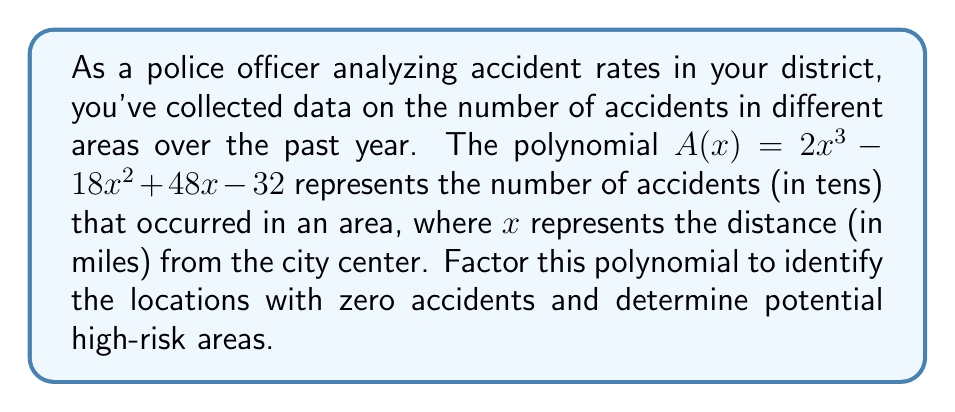Could you help me with this problem? To factor the polynomial $A(x) = 2x^3 - 18x^2 + 48x - 32$, we'll follow these steps:

1) First, let's check if there's a common factor:
   $2x^3 - 18x^2 + 48x - 32 = 2(x^3 - 9x^2 + 24x - 16)$

2) Now, we'll try to factor the expression inside the parentheses. Let's check if $x = 1$ is a root:
   $1^3 - 9(1)^2 + 24(1) - 16 = 1 - 9 + 24 - 16 = 0$
   
   Indeed, $x = 1$ is a root, so $(x - 1)$ is a factor.

3) We can divide the polynomial by $(x - 1)$ to find the other factor:
   
   $x^2 - 8x + 16$

4) This quadratic expression is a perfect square trinomial:
   $x^2 - 8x + 16 = (x - 4)^2$

5) Putting it all together, we get:
   $A(x) = 2x^3 - 18x^2 + 48x - 32 = 2(x - 1)(x - 4)^2$

The roots of this polynomial are $x = 1$ and $x = 4$ (double root). These represent the distances from the city center where the number of accidents is zero.

Interpreting the results:
- At 1 mile and 4 miles from the city center, the accident rate is zero.
- The double root at $x = 4$ suggests that the accident rate not only reaches zero but also changes direction at this point.
- The areas between 0-1 miles and 1-4 miles from the city center are likely to be high-risk areas, as the polynomial is positive in these regions.
- Beyond 4 miles, the accident rate starts to increase again, potentially indicating another risk zone in the suburbs.
Answer: $A(x) = 2(x - 1)(x - 4)^2$ 